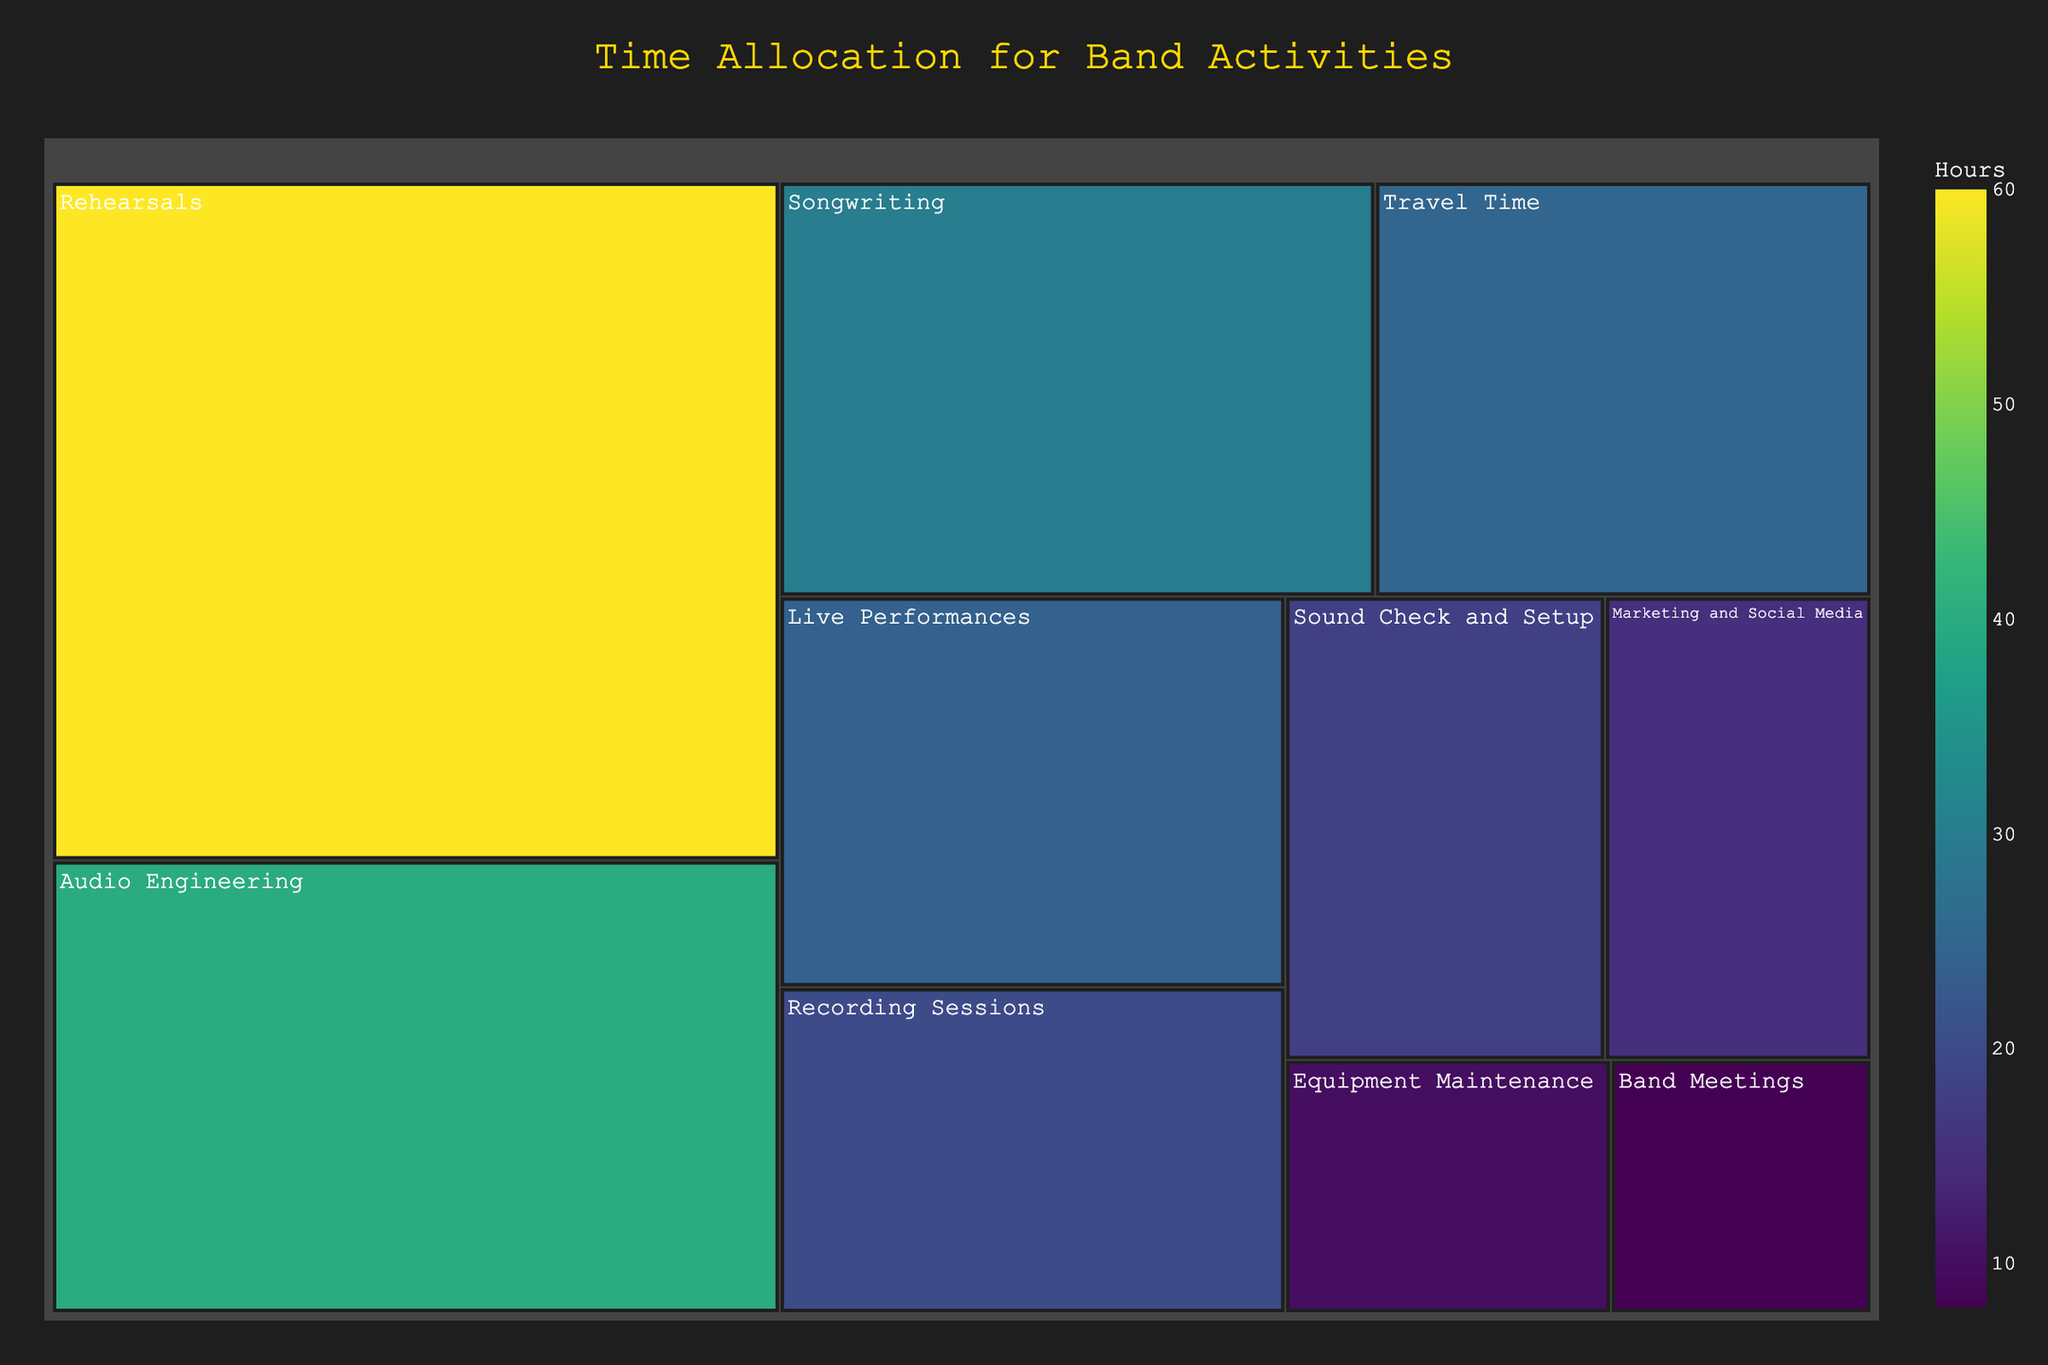What is the title of the treemap? The title of the treemap is displayed at the top center of the figure. It summarizes what the data visualized is about.
Answer: Time Allocation for Band Activities Which activity takes the most hours? The largest section in the treemap will represent the activity that takes the most hours.
Answer: Rehearsals What are the three activities with the least hours allocated? Look for the three smallest sections in the treemap to identify these activities.
Answer: Equipment Maintenance, Band Meetings, Marketing and Social Media How many hours are spent on songwriting and recording sessions combined? Sum the hours for songwriting and recording sessions. Based on the data, it is 30 hours for songwriting and 20 hours for recording sessions.
Answer: 50 Which activity's allocation is closest to travel time? Compare the hours of travel time with other activities and find the closest match. Audio Engineering with 40 hours is the closest to Travel Time with 25 hours as compared to the other activities.
Answer: Audio Engineering What is the difference in hours between live performances and rehearsals? Subtract the hours for live performances from the hours for rehearsals. According to the data, it is 60 - 24.
Answer: 36 How does the time spent on audio engineering compare to marketing and social media? Look at the sizes of the respective sections on the treemap. Audio Engineering is larger. According to the data, audio engineering has more hours (40) compared to marketing and social media (15).
Answer: Audio Engineering has more Of all activities, which two have hours summing closest to 50? Calculate the sum of hours for different pairs and see which closest match 50. Songwriting (30) + Recording Sessions (20) = 50
Answer: Songwriting and Recording Sessions Which activity takes more time: travel time or live performances? Compare the sizes of the sections for travel time and live performances. According to the data, the hours for travel time are 25 and for live performances are 24, making travel time more.
Answer: Travel Time Is more time allocated to sound check and setup than to band meetings? Compare the section sizes for sound check and setup against band meetings. According to the data, sound check and setup (18 hours) take more time than band meetings (8 hours).
Answer: Yes 